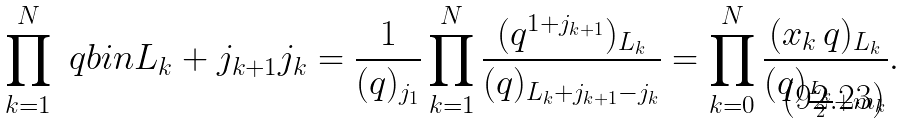Convert formula to latex. <formula><loc_0><loc_0><loc_500><loc_500>\prod _ { k = 1 } ^ { N } \ q b i n { L _ { k } + j _ { k + 1 } } { j _ { k } } = \frac { 1 } { ( q ) _ { j _ { 1 } } } \prod _ { k = 1 } ^ { N } \frac { ( q ^ { 1 + j _ { k + 1 } } ) _ { L _ { k } } } { ( q ) _ { L _ { k } + j _ { k + 1 } - j _ { k } } } = \prod _ { k = 0 } ^ { N } \frac { ( x _ { k } \, q ) _ { L _ { k } } } { ( q ) _ { \frac { L _ { k } } { 2 } + m _ { k } } } .</formula> 